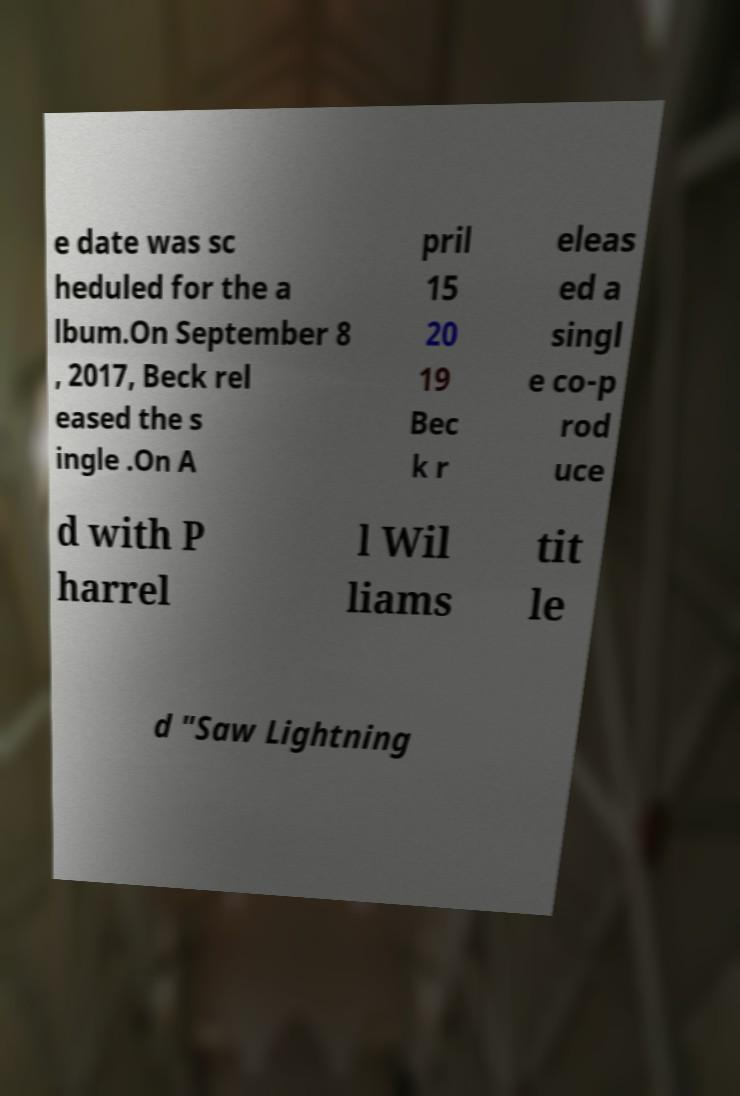There's text embedded in this image that I need extracted. Can you transcribe it verbatim? e date was sc heduled for the a lbum.On September 8 , 2017, Beck rel eased the s ingle .On A pril 15 20 19 Bec k r eleas ed a singl e co-p rod uce d with P harrel l Wil liams tit le d "Saw Lightning 